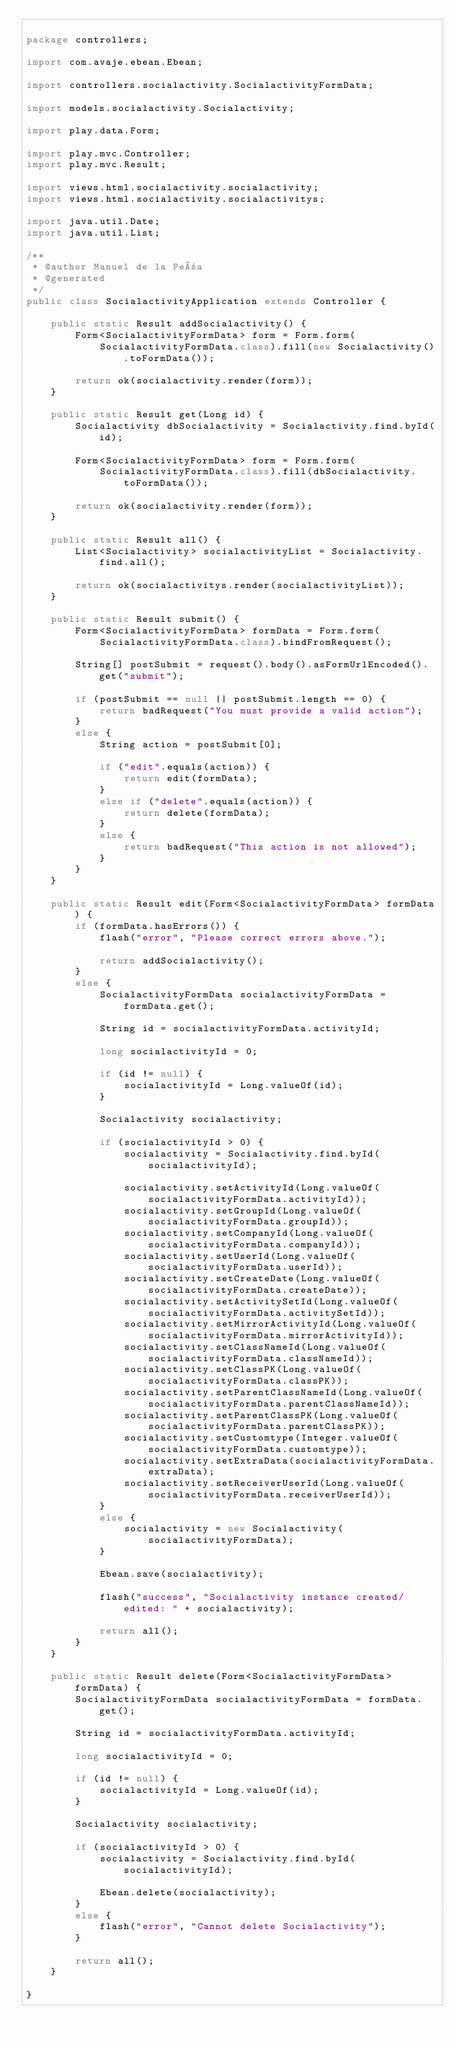Convert code to text. <code><loc_0><loc_0><loc_500><loc_500><_Java_>
package controllers;

import com.avaje.ebean.Ebean;

import controllers.socialactivity.SocialactivityFormData;

import models.socialactivity.Socialactivity;

import play.data.Form;

import play.mvc.Controller;
import play.mvc.Result;

import views.html.socialactivity.socialactivity;
import views.html.socialactivity.socialactivitys;

import java.util.Date;
import java.util.List;

/**
 * @author Manuel de la Peña
 * @generated
 */
public class SocialactivityApplication extends Controller {

	public static Result addSocialactivity() {
		Form<SocialactivityFormData> form = Form.form(
			SocialactivityFormData.class).fill(new Socialactivity().toFormData());

		return ok(socialactivity.render(form));
	}

	public static Result get(Long id) {
		Socialactivity dbSocialactivity = Socialactivity.find.byId(id);

		Form<SocialactivityFormData> form = Form.form(
			SocialactivityFormData.class).fill(dbSocialactivity.toFormData());

		return ok(socialactivity.render(form));
	}

	public static Result all() {
		List<Socialactivity> socialactivityList = Socialactivity.find.all();

		return ok(socialactivitys.render(socialactivityList));
	}

	public static Result submit() {
		Form<SocialactivityFormData> formData = Form.form(
			SocialactivityFormData.class).bindFromRequest();

		String[] postSubmit = request().body().asFormUrlEncoded().get("submit");

		if (postSubmit == null || postSubmit.length == 0) {
			return badRequest("You must provide a valid action");
		}
		else {
			String action = postSubmit[0];

			if ("edit".equals(action)) {
				return edit(formData);
			}
			else if ("delete".equals(action)) {
				return delete(formData);
			}
			else {
				return badRequest("This action is not allowed");
			}
		}
	}

	public static Result edit(Form<SocialactivityFormData> formData) {
		if (formData.hasErrors()) {
			flash("error", "Please correct errors above.");

			return addSocialactivity();
		}
		else {
			SocialactivityFormData socialactivityFormData = formData.get();

			String id = socialactivityFormData.activityId;

			long socialactivityId = 0;

			if (id != null) {
				socialactivityId = Long.valueOf(id);
			}

			Socialactivity socialactivity;

			if (socialactivityId > 0) {
				socialactivity = Socialactivity.find.byId(socialactivityId);

				socialactivity.setActivityId(Long.valueOf(socialactivityFormData.activityId));
				socialactivity.setGroupId(Long.valueOf(socialactivityFormData.groupId));
				socialactivity.setCompanyId(Long.valueOf(socialactivityFormData.companyId));
				socialactivity.setUserId(Long.valueOf(socialactivityFormData.userId));
				socialactivity.setCreateDate(Long.valueOf(socialactivityFormData.createDate));
				socialactivity.setActivitySetId(Long.valueOf(socialactivityFormData.activitySetId));
				socialactivity.setMirrorActivityId(Long.valueOf(socialactivityFormData.mirrorActivityId));
				socialactivity.setClassNameId(Long.valueOf(socialactivityFormData.classNameId));
				socialactivity.setClassPK(Long.valueOf(socialactivityFormData.classPK));
				socialactivity.setParentClassNameId(Long.valueOf(socialactivityFormData.parentClassNameId));
				socialactivity.setParentClassPK(Long.valueOf(socialactivityFormData.parentClassPK));
				socialactivity.setCustomtype(Integer.valueOf(socialactivityFormData.customtype));
				socialactivity.setExtraData(socialactivityFormData.extraData);
				socialactivity.setReceiverUserId(Long.valueOf(socialactivityFormData.receiverUserId));
			}
			else {
				socialactivity = new Socialactivity(socialactivityFormData);
			}

			Ebean.save(socialactivity);

			flash("success", "Socialactivity instance created/edited: " + socialactivity);

			return all();
		}
	}

	public static Result delete(Form<SocialactivityFormData> formData) {
		SocialactivityFormData socialactivityFormData = formData.get();

		String id = socialactivityFormData.activityId;

		long socialactivityId = 0;

		if (id != null) {
			socialactivityId = Long.valueOf(id);
		}

		Socialactivity socialactivity;

		if (socialactivityId > 0) {
			socialactivity = Socialactivity.find.byId(socialactivityId);

			Ebean.delete(socialactivity);
		}
		else {
			flash("error", "Cannot delete Socialactivity");
		}

		return all();
	}

}
</code> 